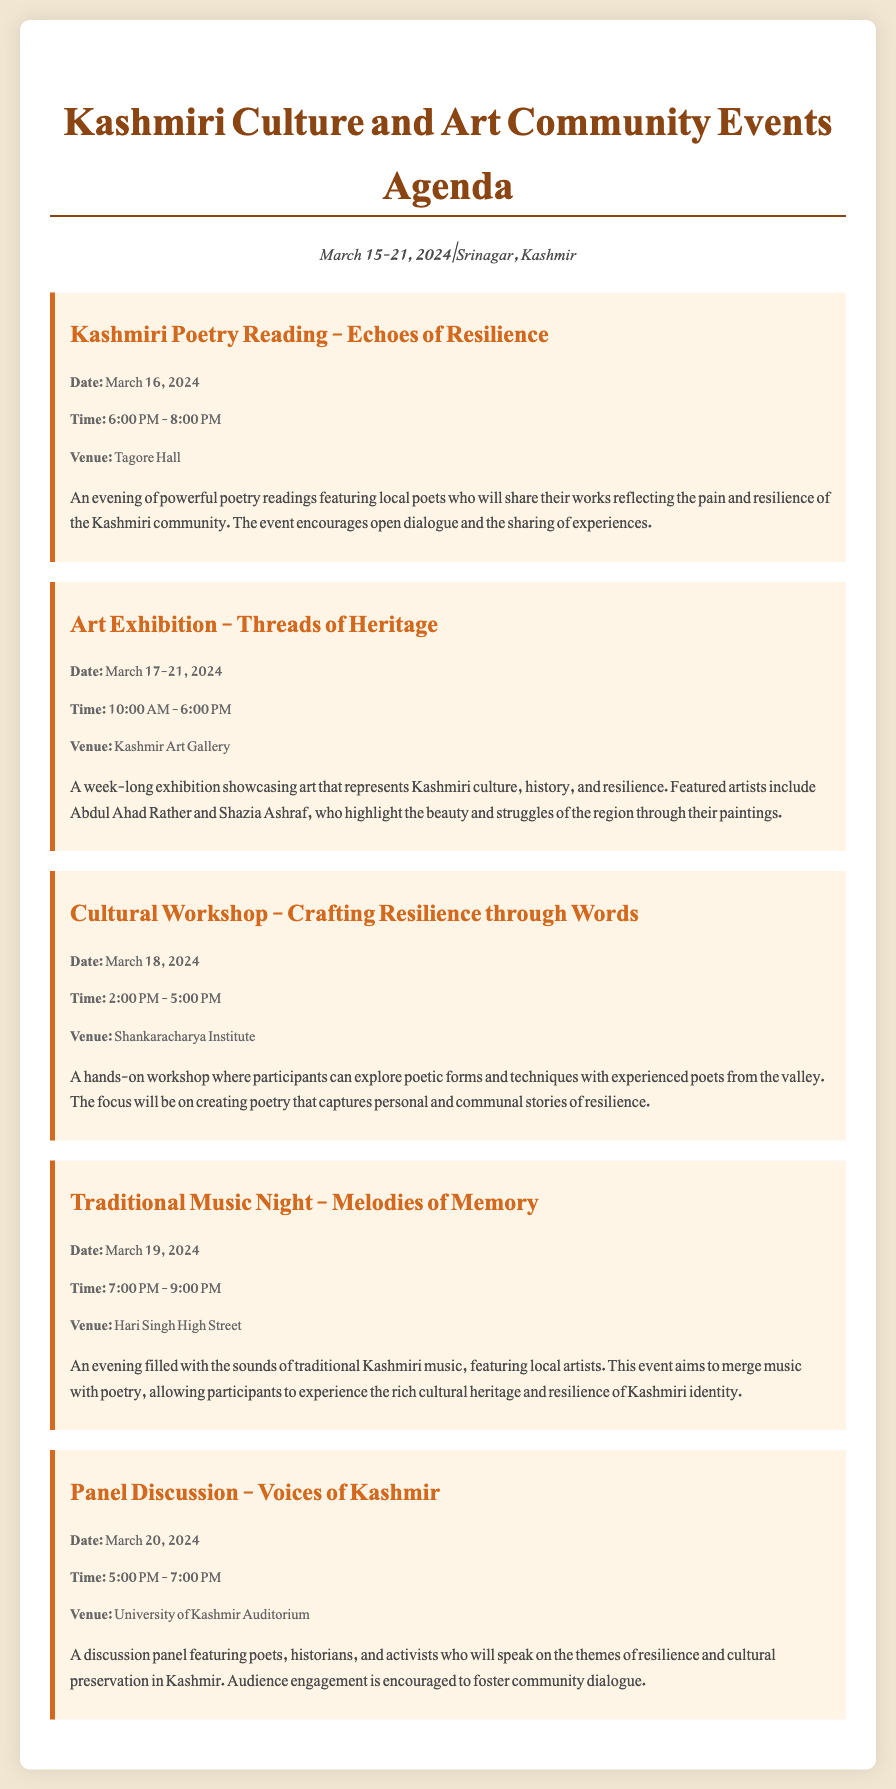What is the date of the poetry reading event? The poetry reading event is scheduled for March 16, 2024.
Answer: March 16, 2024 What venue will host the art exhibition? The art exhibition will take place at Kashmir Art Gallery.
Answer: Kashmir Art Gallery How long will the art exhibition run? The art exhibition will run from March 17 to March 21, 2024.
Answer: March 17-21, 2024 What time does the cultural workshop start? The cultural workshop starts at 2:00 PM.
Answer: 2:00 PM Which event focuses on traditional music? The event titled "Traditional Music Night - Melodies of Memory" focuses on traditional music.
Answer: Traditional Music Night - Melodies of Memory What is the main theme of the panel discussion? The main theme of the panel discussion is resilience and cultural preservation in Kashmir.
Answer: Resilience and cultural preservation Who are the featured artists in the art exhibition? The featured artists include Abdul Ahad Rather and Shazia Ashraf.
Answer: Abdul Ahad Rather and Shazia Ashraf What type of workshop is scheduled for March 18? A cultural workshop focusing on poetic forms and techniques is scheduled for March 18.
Answer: Cultural workshop 